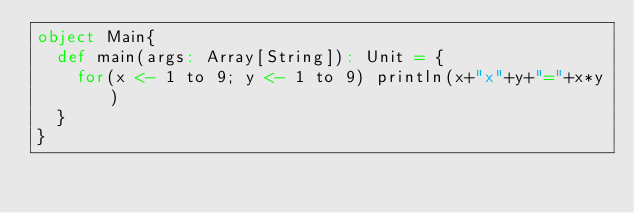Convert code to text. <code><loc_0><loc_0><loc_500><loc_500><_Scala_>object Main{
  def main(args: Array[String]): Unit = {
    for(x <- 1 to 9; y <- 1 to 9) println(x+"x"+y+"="+x*y)
  }
}</code> 